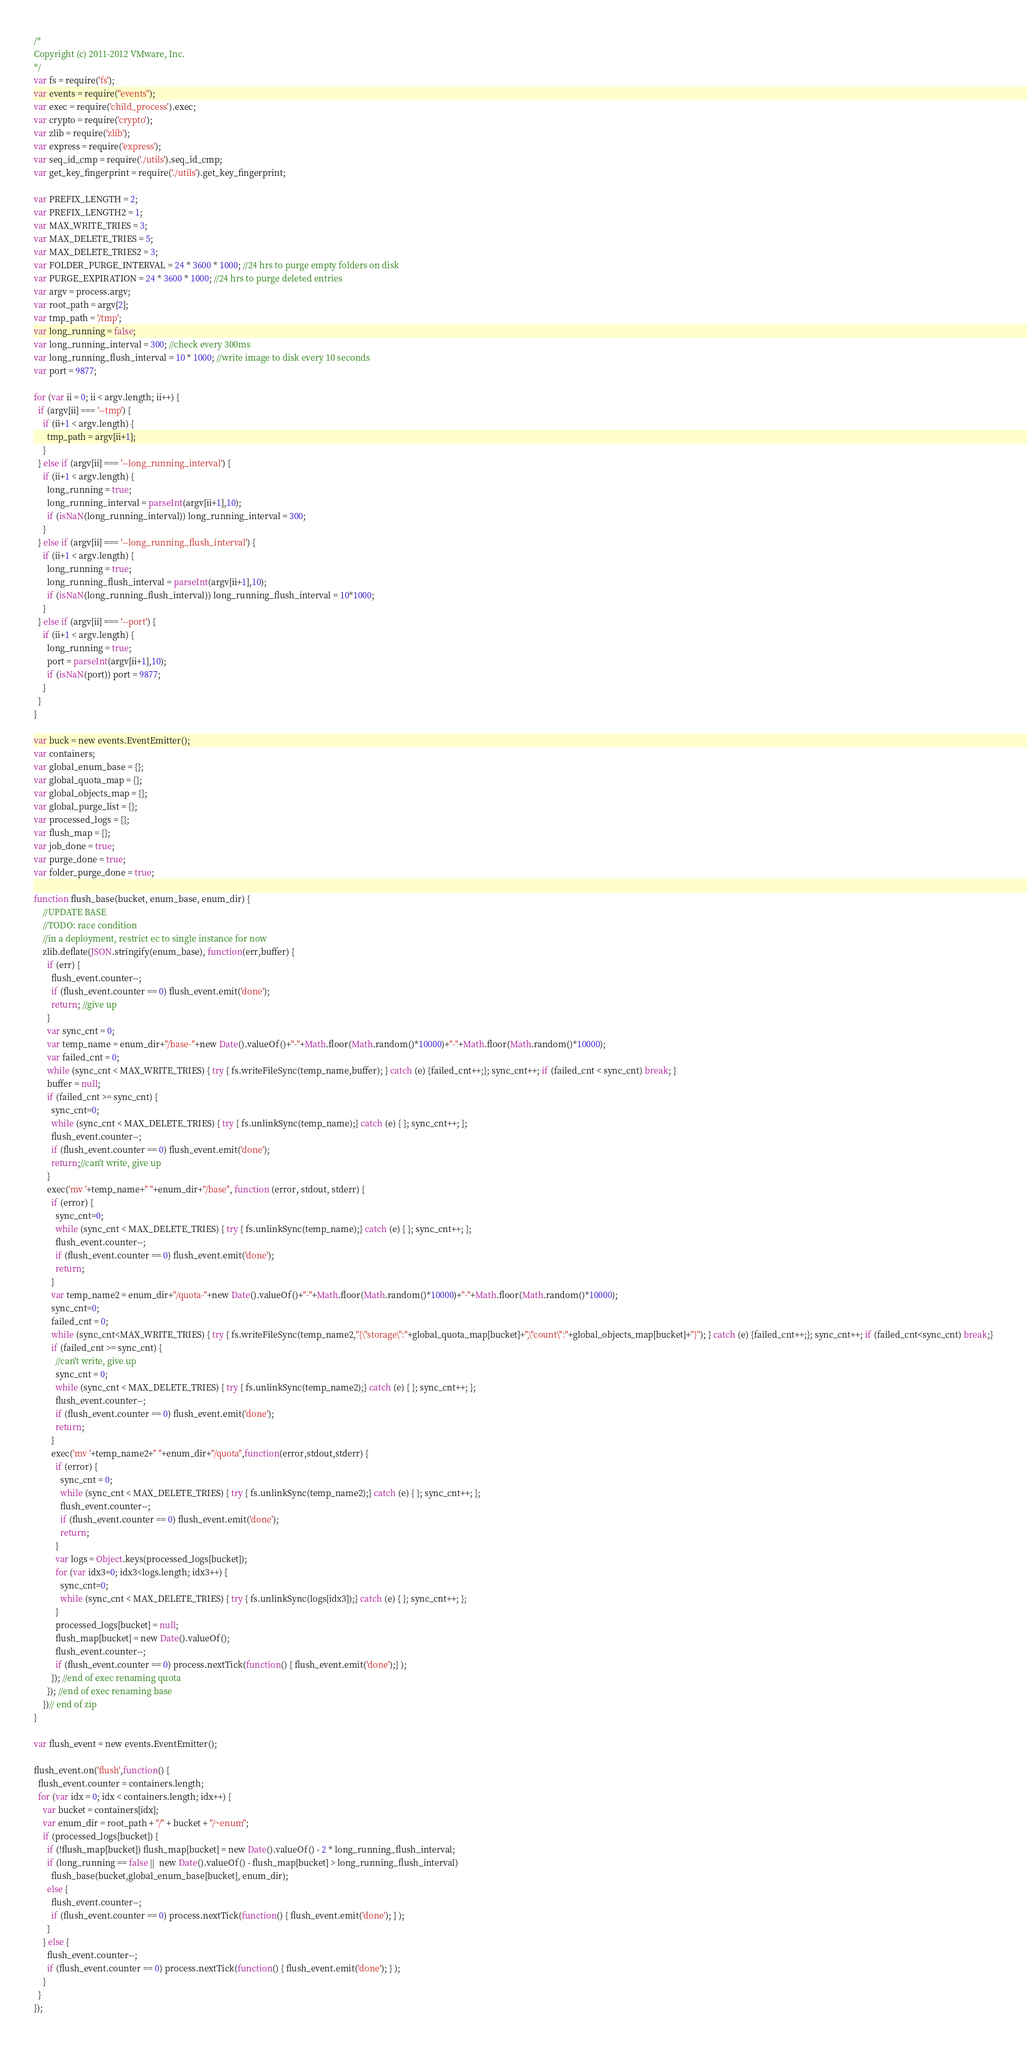<code> <loc_0><loc_0><loc_500><loc_500><_JavaScript_>/*
Copyright (c) 2011-2012 VMware, Inc.
*/
var fs = require('fs');
var events = require("events");
var exec = require('child_process').exec;
var crypto = require('crypto');
var zlib = require('zlib');
var express = require('express');
var seq_id_cmp = require('./utils').seq_id_cmp;
var get_key_fingerprint = require('./utils').get_key_fingerprint;

var PREFIX_LENGTH = 2;
var PREFIX_LENGTH2 = 1;
var MAX_WRITE_TRIES = 3;
var MAX_DELETE_TRIES = 5;
var MAX_DELETE_TRIES2 = 3;
var FOLDER_PURGE_INTERVAL = 24 * 3600 * 1000; //24 hrs to purge empty folders on disk
var PURGE_EXPIRATION = 24 * 3600 * 1000; //24 hrs to purge deleted entries
var argv = process.argv;
var root_path = argv[2];
var tmp_path = '/tmp';
var long_running = false;
var long_running_interval = 300; //check every 300ms
var long_running_flush_interval = 10 * 1000; //write image to disk every 10 seconds
var port = 9877;

for (var ii = 0; ii < argv.length; ii++) {
  if (argv[ii] === '--tmp') {
    if (ii+1 < argv.length) {
      tmp_path = argv[ii+1];
    }
  } else if (argv[ii] === '--long_running_interval') {
    if (ii+1 < argv.length) {
      long_running = true;
      long_running_interval = parseInt(argv[ii+1],10);
      if (isNaN(long_running_interval)) long_running_interval = 300;
    }
  } else if (argv[ii] === '--long_running_flush_interval') {
    if (ii+1 < argv.length) {
      long_running = true;
      long_running_flush_interval = parseInt(argv[ii+1],10);
      if (isNaN(long_running_flush_interval)) long_running_flush_interval = 10*1000;
    }
  } else if (argv[ii] === '--port') {
    if (ii+1 < argv.length) {
      long_running = true;
      port = parseInt(argv[ii+1],10);
      if (isNaN(port)) port = 9877;
    }
  }
}

var buck = new events.EventEmitter();
var containers;
var global_enum_base = {};
var global_quota_map = {};
var global_objects_map = {};
var global_purge_list = {};
var processed_logs = {};
var flush_map = {};
var job_done = true;
var purge_done = true;
var folder_purge_done = true;

function flush_base(bucket, enum_base, enum_dir) {
    //UPDATE BASE
    //TODO: race condition
    //in a deployment, restrict ec to single instance for now
    zlib.deflate(JSON.stringify(enum_base), function(err,buffer) {
      if (err) {
        flush_event.counter--;
        if (flush_event.counter == 0) flush_event.emit('done');
        return; //give up
      }
      var sync_cnt = 0;
      var temp_name = enum_dir+"/base-"+new Date().valueOf()+"-"+Math.floor(Math.random()*10000)+"-"+Math.floor(Math.random()*10000);
      var failed_cnt = 0;
      while (sync_cnt < MAX_WRITE_TRIES) { try { fs.writeFileSync(temp_name,buffer); } catch (e) {failed_cnt++;}; sync_cnt++; if (failed_cnt < sync_cnt) break; }
      buffer = null;
      if (failed_cnt >= sync_cnt) { 
        sync_cnt=0;
        while (sync_cnt < MAX_DELETE_TRIES) { try { fs.unlinkSync(temp_name);} catch (e) { }; sync_cnt++; };
        flush_event.counter--;
        if (flush_event.counter == 0) flush_event.emit('done');
        return;//can't write, give up
      }
      exec('mv '+temp_name+" "+enum_dir+"/base", function (error, stdout, stderr) {
        if (error) {
          sync_cnt=0;
          while (sync_cnt < MAX_DELETE_TRIES) { try { fs.unlinkSync(temp_name);} catch (e) { }; sync_cnt++; };
          flush_event.counter--;
          if (flush_event.counter == 0) flush_event.emit('done');
          return;
        }
        var temp_name2 = enum_dir+"/quota-"+new Date().valueOf()+"-"+Math.floor(Math.random()*10000)+"-"+Math.floor(Math.random()*10000);
        sync_cnt=0;
        failed_cnt = 0;
        while (sync_cnt<MAX_WRITE_TRIES) { try { fs.writeFileSync(temp_name2,"{\"storage\":"+global_quota_map[bucket]+",\"count\":"+global_objects_map[bucket]+"}"); } catch (e) {failed_cnt++;}; sync_cnt++; if (failed_cnt<sync_cnt) break;}
        if (failed_cnt >= sync_cnt) {
          //can't write, give up
          sync_cnt = 0;
          while (sync_cnt < MAX_DELETE_TRIES) { try { fs.unlinkSync(temp_name2);} catch (e) { }; sync_cnt++; };
          flush_event.counter--;
          if (flush_event.counter == 0) flush_event.emit('done');
          return;
        }
        exec('mv '+temp_name2+" "+enum_dir+"/quota",function(error,stdout,stderr) {
          if (error) {
            sync_cnt = 0;
            while (sync_cnt < MAX_DELETE_TRIES) { try { fs.unlinkSync(temp_name2);} catch (e) { }; sync_cnt++; };
            flush_event.counter--;
            if (flush_event.counter == 0) flush_event.emit('done');
            return;
          }
          var logs = Object.keys(processed_logs[bucket]);
          for (var idx3=0; idx3<logs.length; idx3++) {
            sync_cnt=0;
            while (sync_cnt < MAX_DELETE_TRIES) { try { fs.unlinkSync(logs[idx3]);} catch (e) { }; sync_cnt++; };
          }
          processed_logs[bucket] = null;
          flush_map[bucket] = new Date().valueOf();
          flush_event.counter--;
          if (flush_event.counter == 0) process.nextTick(function() { flush_event.emit('done');} );
        }); //end of exec renaming quota
      }); //end of exec renaming base 
    })// end of zip
}

var flush_event = new events.EventEmitter();

flush_event.on('flush',function() {
  flush_event.counter = containers.length;
  for (var idx = 0; idx < containers.length; idx++) {
    var bucket = containers[idx];
    var enum_dir = root_path + "/" + bucket + "/~enum";
    if (processed_logs[bucket]) {
      if (!flush_map[bucket]) flush_map[bucket] = new Date().valueOf() - 2 * long_running_flush_interval;
      if (long_running == false ||  new Date().valueOf() - flush_map[bucket] > long_running_flush_interval)
        flush_base(bucket,global_enum_base[bucket], enum_dir);
      else {
        flush_event.counter--;
        if (flush_event.counter == 0) process.nextTick(function() { flush_event.emit('done'); } );
      }
    } else {
      flush_event.counter--;
      if (flush_event.counter == 0) process.nextTick(function() { flush_event.emit('done'); } );
    }
  }
});
</code> 